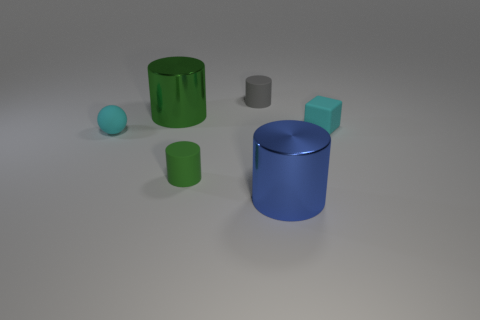Do the green cylinder that is left of the green rubber cylinder and the blue object have the same material? Yes, the green cylinder to the left of the green rubber cylinder and the blue object appear to be made of the same type of smooth, matte material, likely a kind of plastic or painted metal, as suggested by their similar reflections and texture. 